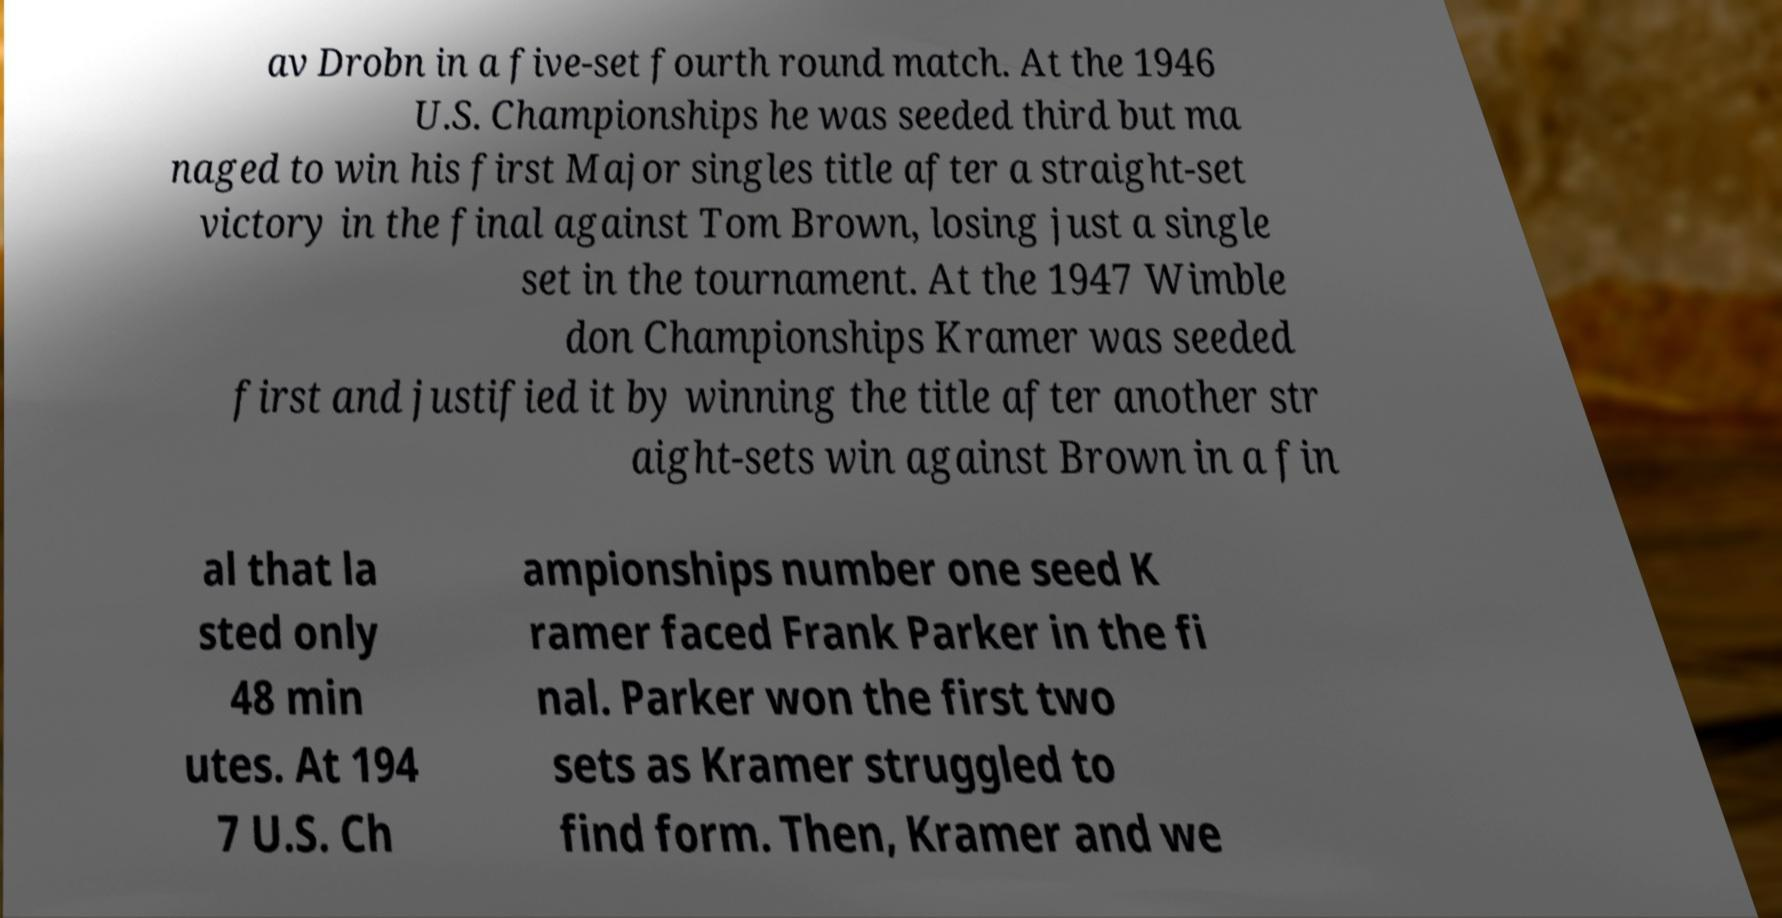For documentation purposes, I need the text within this image transcribed. Could you provide that? av Drobn in a five-set fourth round match. At the 1946 U.S. Championships he was seeded third but ma naged to win his first Major singles title after a straight-set victory in the final against Tom Brown, losing just a single set in the tournament. At the 1947 Wimble don Championships Kramer was seeded first and justified it by winning the title after another str aight-sets win against Brown in a fin al that la sted only 48 min utes. At 194 7 U.S. Ch ampionships number one seed K ramer faced Frank Parker in the fi nal. Parker won the first two sets as Kramer struggled to find form. Then, Kramer and we 